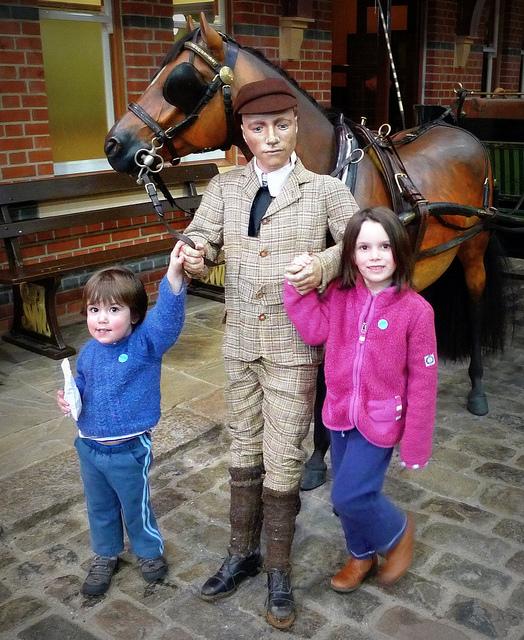Is the man in the hat real?
Write a very short answer. No. What material is the wall made of?
Give a very brief answer. Brick. Are the people real?
Write a very short answer. No. 